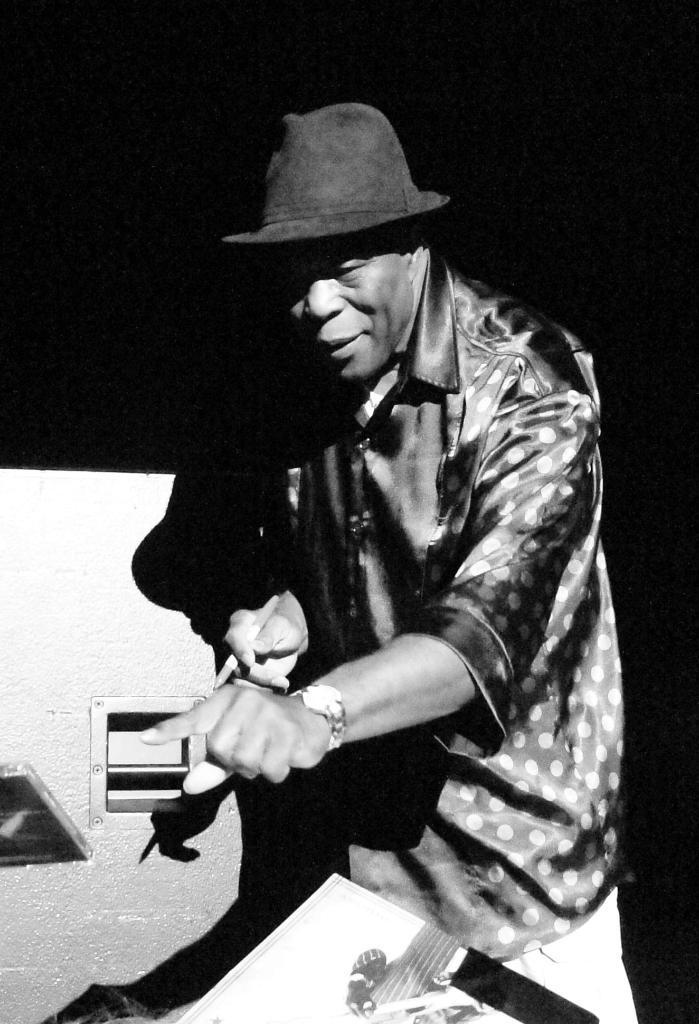What is the main subject of the image? There is a man in the image. What is the man wearing on his upper body? The man is wearing a shirt. What type of headwear is the man wearing? The man is wearing a hat on his head. What is the color scheme of the image? The image is black and white. What can be observed about the background of the image? The background of the image is completely dark. What type of soap is the man using in the image? There is no soap present in the image. What agreement did the man make with the other person in the image? There is no other person present in the image, and no agreement is mentioned or implied. 